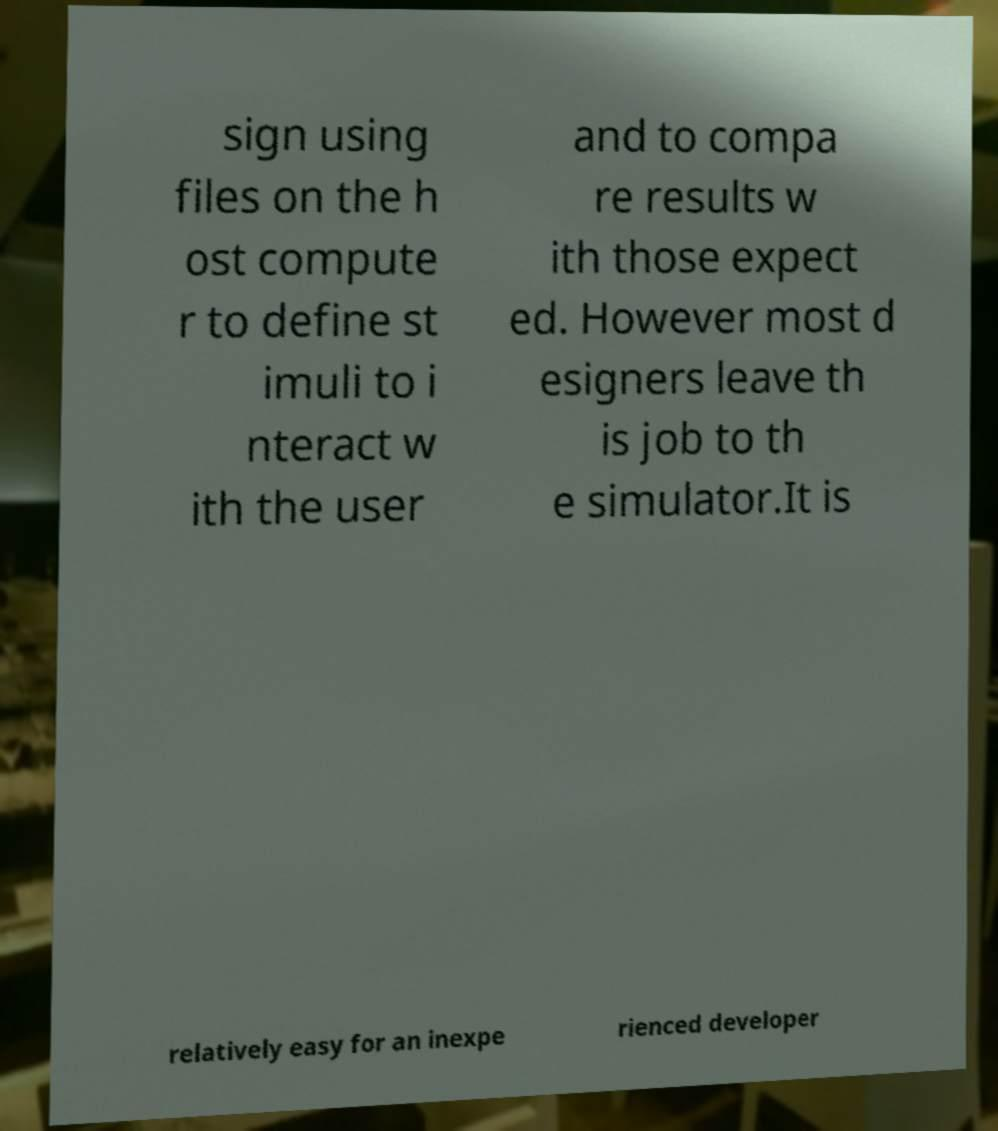For documentation purposes, I need the text within this image transcribed. Could you provide that? sign using files on the h ost compute r to define st imuli to i nteract w ith the user and to compa re results w ith those expect ed. However most d esigners leave th is job to th e simulator.It is relatively easy for an inexpe rienced developer 